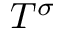Convert formula to latex. <formula><loc_0><loc_0><loc_500><loc_500>T ^ { \sigma }</formula> 